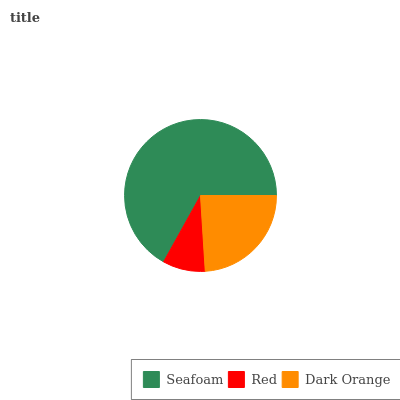Is Red the minimum?
Answer yes or no. Yes. Is Seafoam the maximum?
Answer yes or no. Yes. Is Dark Orange the minimum?
Answer yes or no. No. Is Dark Orange the maximum?
Answer yes or no. No. Is Dark Orange greater than Red?
Answer yes or no. Yes. Is Red less than Dark Orange?
Answer yes or no. Yes. Is Red greater than Dark Orange?
Answer yes or no. No. Is Dark Orange less than Red?
Answer yes or no. No. Is Dark Orange the high median?
Answer yes or no. Yes. Is Dark Orange the low median?
Answer yes or no. Yes. Is Seafoam the high median?
Answer yes or no. No. Is Red the low median?
Answer yes or no. No. 